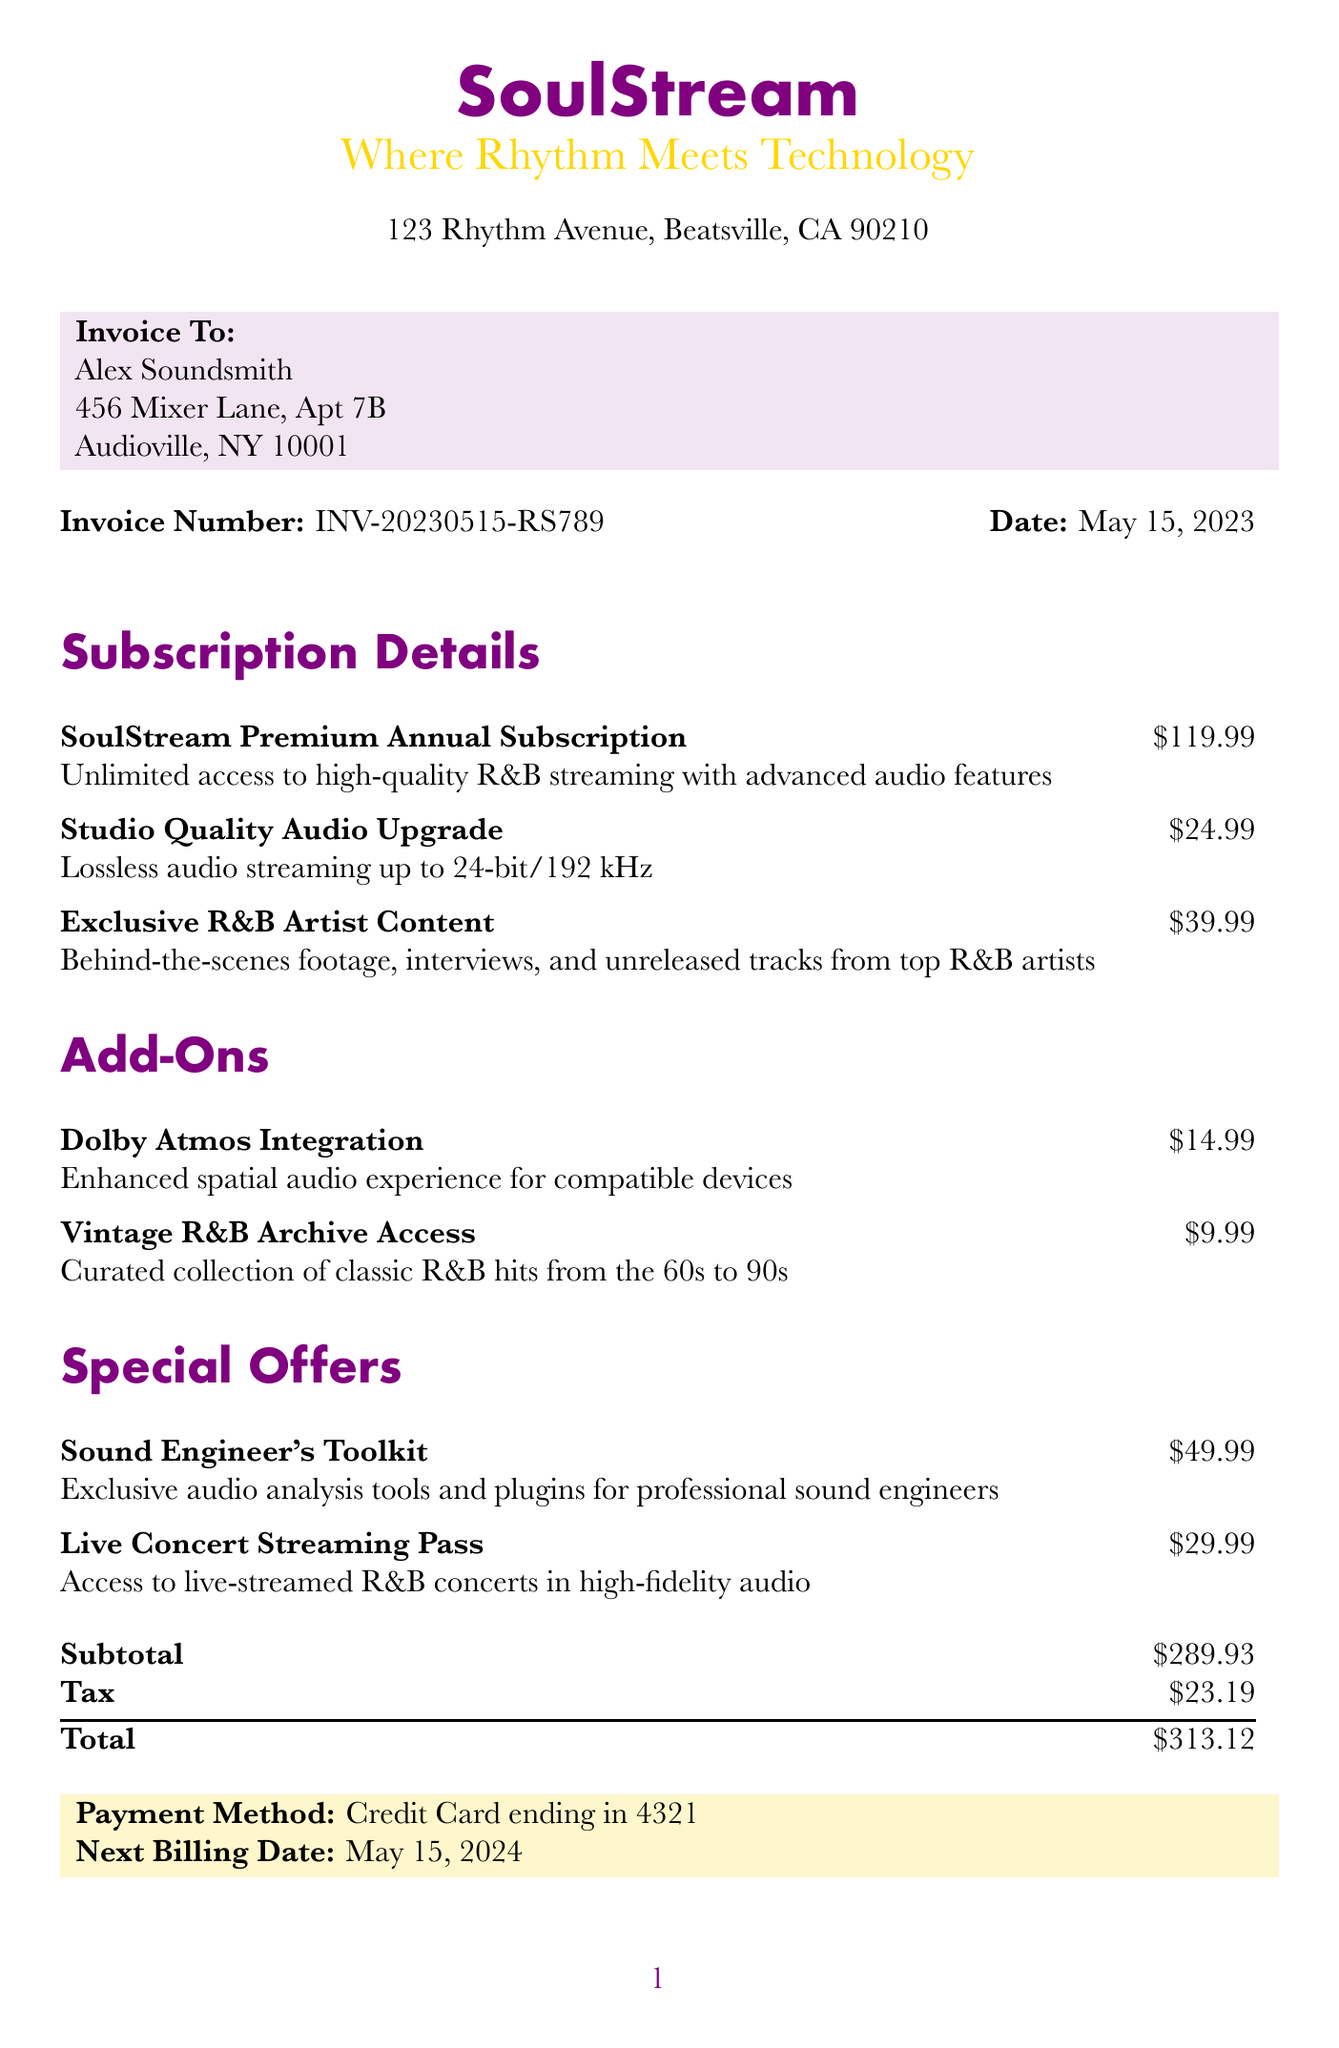What is the invoice number? The invoice number is specifically listed in the document, which is used for tracking the invoice.
Answer: INV-20230515-RS789 What is the total amount due? The total amount due is the final charge calculated including the subtotal and tax.
Answer: $313.12 What is the customer's name? The customer's name appears at the top of the invoice, identifying the individual responsible for the payment.
Answer: Alex Soundsmith What is the price of the Studio Quality Audio Upgrade? The price of the Studio Quality Audio Upgrade is detailed in the subscription section of the document.
Answer: $24.99 What is the payment method used? The payment method is presented towards the end of the document, indicating how the payment will be processed.
Answer: Credit Card ending in 4321 How many items are in the subscription details? The number of items can be counted from the subscription details section, highlighting the different offerings.
Answer: 3 What is the next billing date? The next billing date is specified in the document, indicating when the subscription will renew.
Answer: May 15, 2024 What special offer provides access to live concerts? The special offer details include particular services available at a premium, one of which is specifically for live concerts.
Answer: Live Concert Streaming Pass What additional option enhances spatial audio experience? The document includes various add-ons, one of which is dedicated to improving audio quality through enhanced features.
Answer: Dolby Atmos Integration 